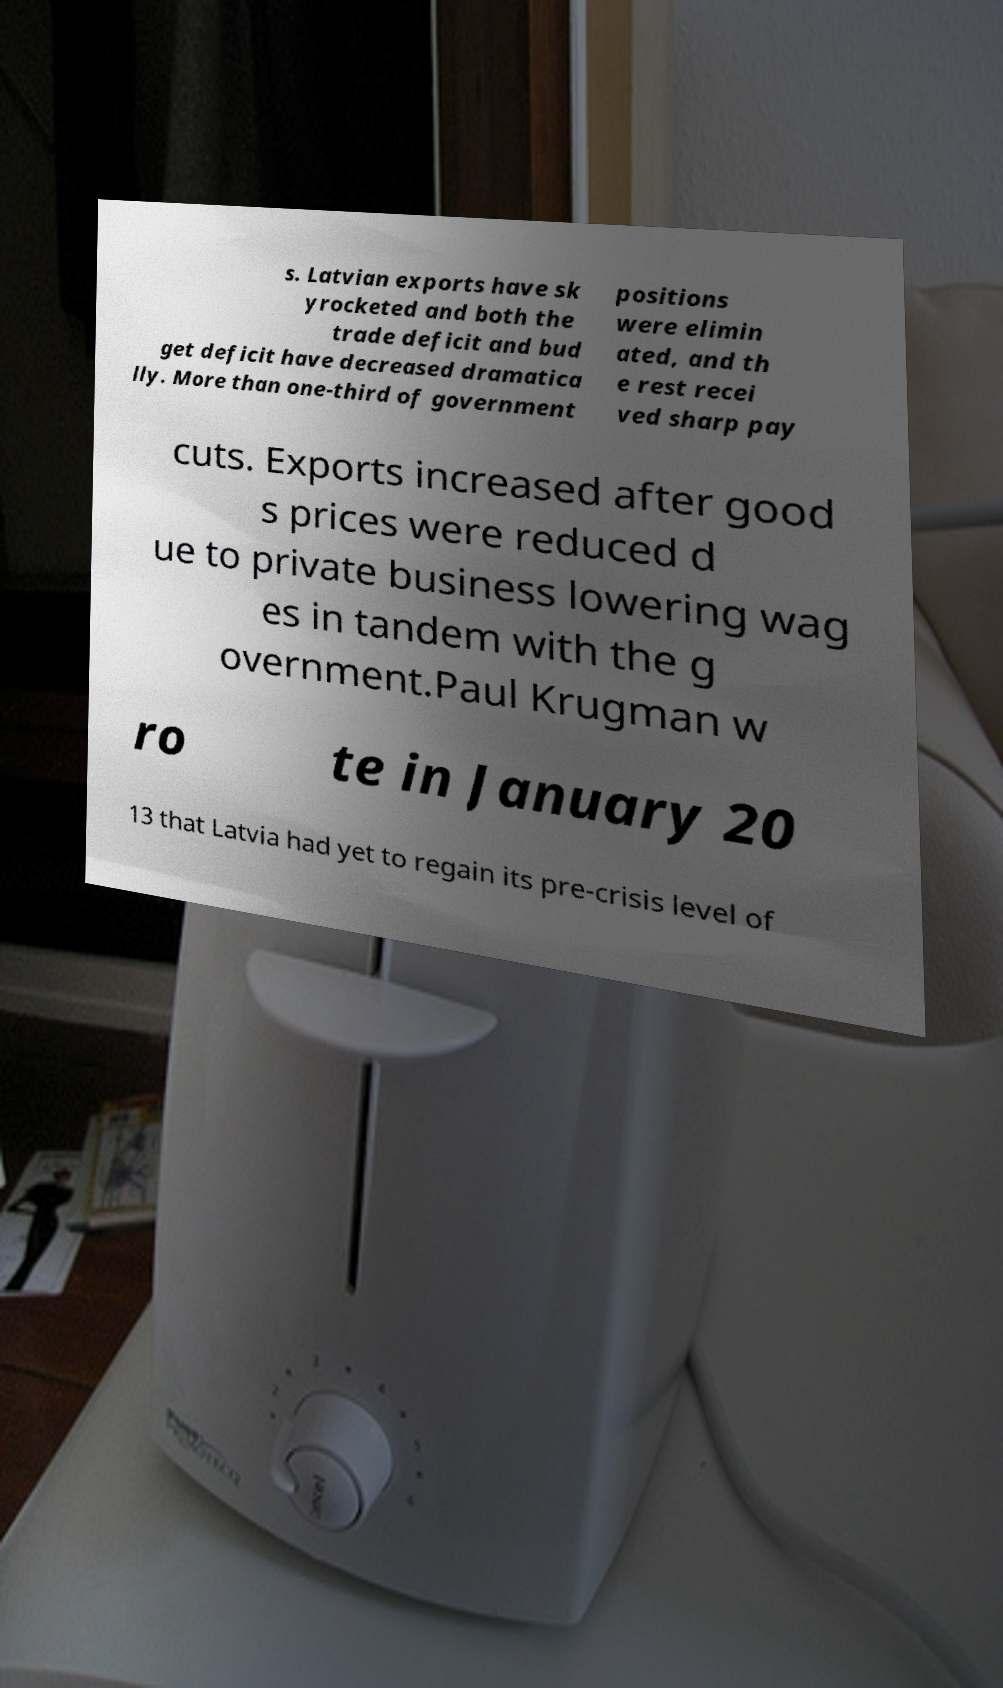Could you extract and type out the text from this image? s. Latvian exports have sk yrocketed and both the trade deficit and bud get deficit have decreased dramatica lly. More than one-third of government positions were elimin ated, and th e rest recei ved sharp pay cuts. Exports increased after good s prices were reduced d ue to private business lowering wag es in tandem with the g overnment.Paul Krugman w ro te in January 20 13 that Latvia had yet to regain its pre-crisis level of 